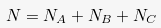Convert formula to latex. <formula><loc_0><loc_0><loc_500><loc_500>N = N _ { A } + N _ { B } + N _ { C }</formula> 